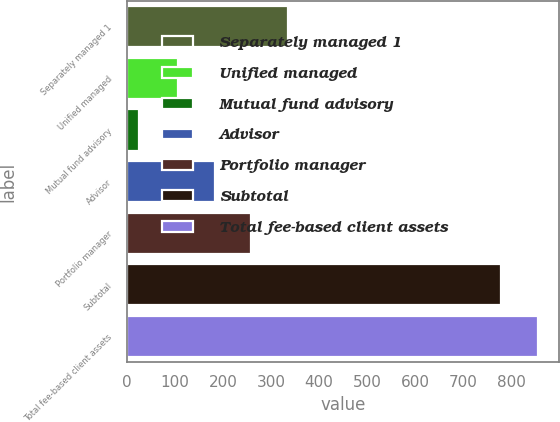Convert chart. <chart><loc_0><loc_0><loc_500><loc_500><bar_chart><fcel>Separately managed 1<fcel>Unified managed<fcel>Mutual fund advisory<fcel>Advisor<fcel>Portfolio manager<fcel>Subtotal<fcel>Total fee-based client assets<nl><fcel>336<fcel>105<fcel>25<fcel>182<fcel>259<fcel>780<fcel>857<nl></chart> 